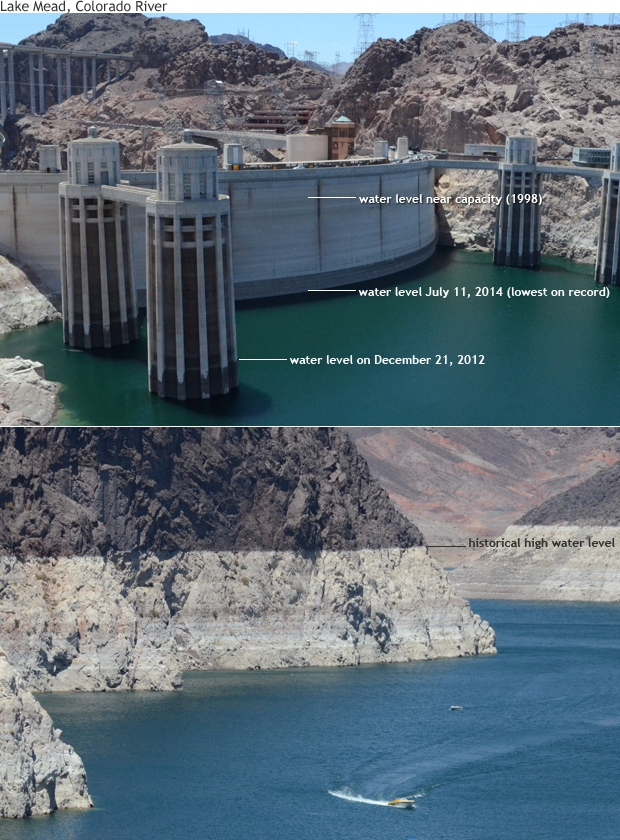What could be the future outlook for Lake Mead if current trends continue? If the current trends of water consumption, drought frequency, and climate change continue, the future outlook for Lake Mead could be increasingly dire. The lake may see even lower water levels, potentially approaching critical thresholds that could jeopardize water supply for millions of people in the region. This scenario could amplify water scarcity issues, leading to stricter water use regulations and more severe conservation measures. The local ecosystem could suffer further degradation, impacting wildlife that depends on the lake. To prevent such outcomes, it is imperative to adopt comprehensive water management strategies, increase reliance on sustainable and alternative water sources, and address climate change mitigation and adaptation measures effectively. Can you suggest some innovative and creative solutions for sustaining Lake Mead's water levels? To sustain Lake Mead's water levels, we could explore several innovative and creative solutions. One idea is to implement large-scale cloud seeding to enhance precipitation in the watershed. Another approach could involve developing advanced desalination technologies to convert seawater to fresh water, reducing dependency on the reservoir. Additionally, promoting urban green infrastructure, such as green roofs and rain gardens, can increase water retention and reduce runoff. Investing in smart irrigation systems and precision agriculture can optimize water use in farming, maximizing efficiency. A futuristic solution might be the development of large artificial aquifers that can store excess rainwater and release it gradually during dry periods. International cooperation on shared water resources and technology exchange can also play a pivotal role in maintaining sustainable water levels in Lake Mead. 